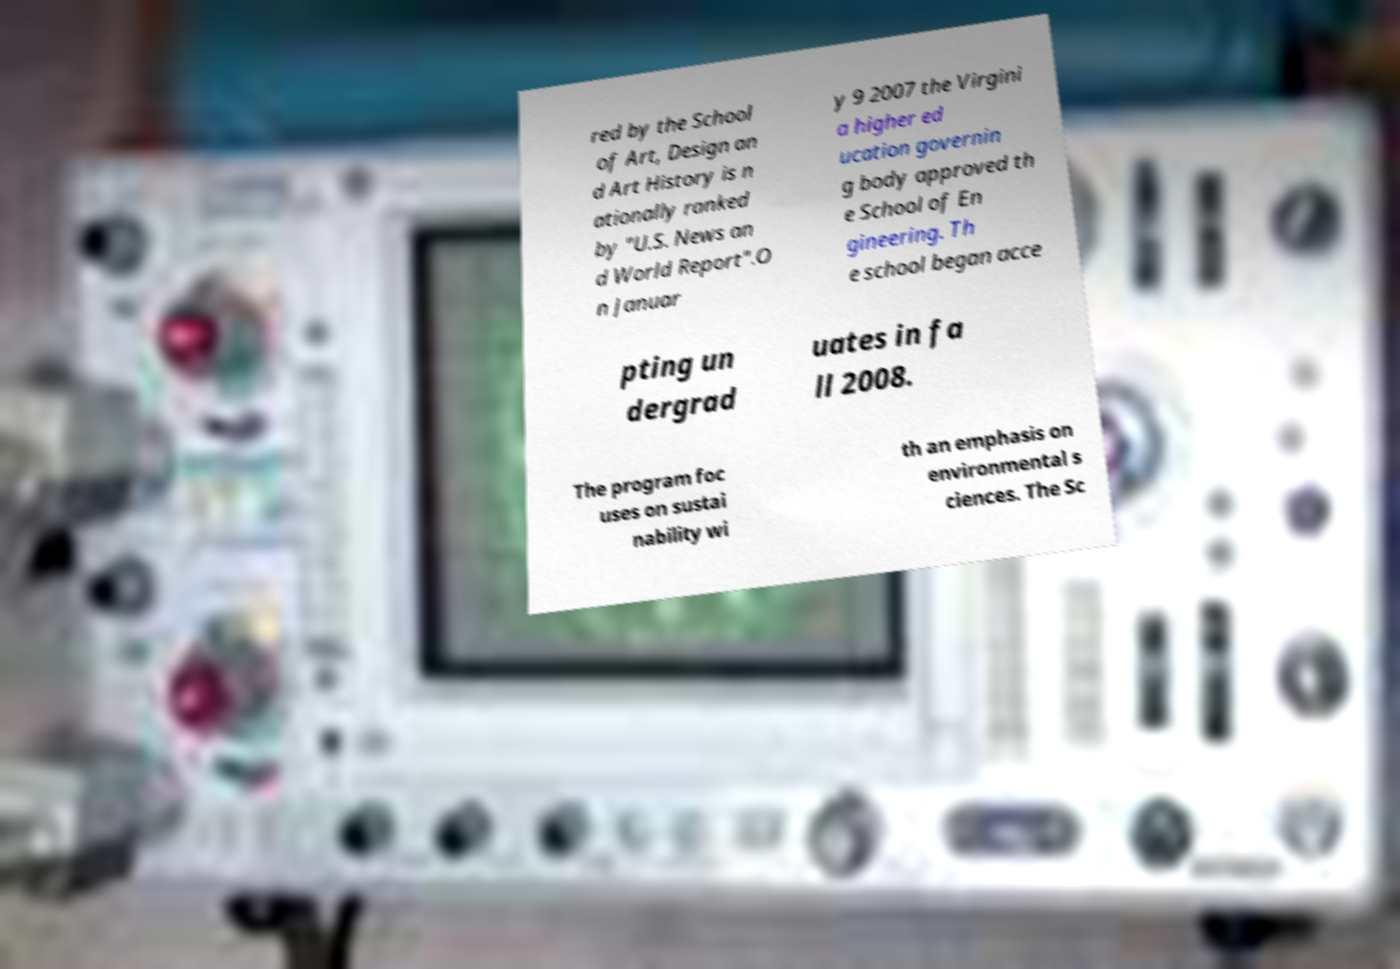Please read and relay the text visible in this image. What does it say? red by the School of Art, Design an d Art History is n ationally ranked by "U.S. News an d World Report".O n Januar y 9 2007 the Virgini a higher ed ucation governin g body approved th e School of En gineering. Th e school began acce pting un dergrad uates in fa ll 2008. The program foc uses on sustai nability wi th an emphasis on environmental s ciences. The Sc 